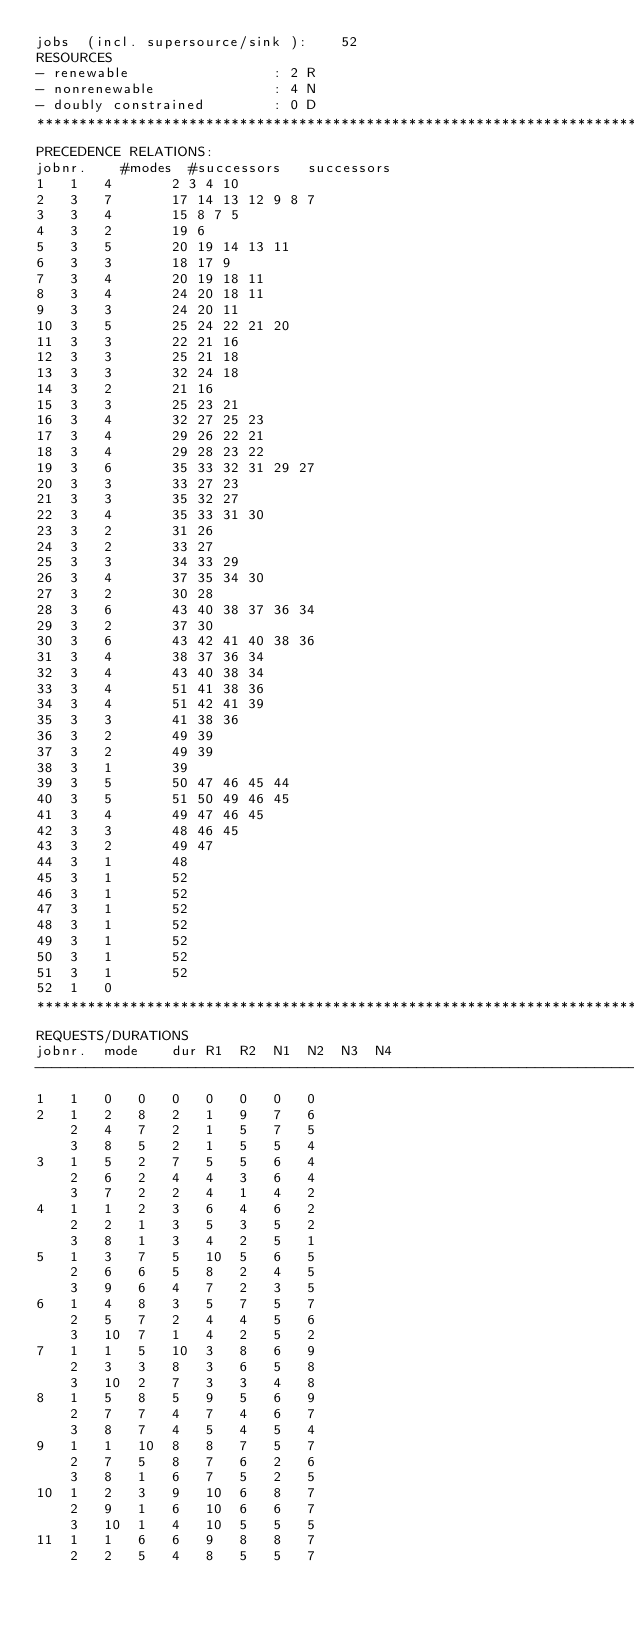Convert code to text. <code><loc_0><loc_0><loc_500><loc_500><_ObjectiveC_>jobs  (incl. supersource/sink ):	52
RESOURCES
- renewable                 : 2 R
- nonrenewable              : 4 N
- doubly constrained        : 0 D
************************************************************************
PRECEDENCE RELATIONS:
jobnr.    #modes  #successors   successors
1	1	4		2 3 4 10 
2	3	7		17 14 13 12 9 8 7 
3	3	4		15 8 7 5 
4	3	2		19 6 
5	3	5		20 19 14 13 11 
6	3	3		18 17 9 
7	3	4		20 19 18 11 
8	3	4		24 20 18 11 
9	3	3		24 20 11 
10	3	5		25 24 22 21 20 
11	3	3		22 21 16 
12	3	3		25 21 18 
13	3	3		32 24 18 
14	3	2		21 16 
15	3	3		25 23 21 
16	3	4		32 27 25 23 
17	3	4		29 26 22 21 
18	3	4		29 28 23 22 
19	3	6		35 33 32 31 29 27 
20	3	3		33 27 23 
21	3	3		35 32 27 
22	3	4		35 33 31 30 
23	3	2		31 26 
24	3	2		33 27 
25	3	3		34 33 29 
26	3	4		37 35 34 30 
27	3	2		30 28 
28	3	6		43 40 38 37 36 34 
29	3	2		37 30 
30	3	6		43 42 41 40 38 36 
31	3	4		38 37 36 34 
32	3	4		43 40 38 34 
33	3	4		51 41 38 36 
34	3	4		51 42 41 39 
35	3	3		41 38 36 
36	3	2		49 39 
37	3	2		49 39 
38	3	1		39 
39	3	5		50 47 46 45 44 
40	3	5		51 50 49 46 45 
41	3	4		49 47 46 45 
42	3	3		48 46 45 
43	3	2		49 47 
44	3	1		48 
45	3	1		52 
46	3	1		52 
47	3	1		52 
48	3	1		52 
49	3	1		52 
50	3	1		52 
51	3	1		52 
52	1	0		
************************************************************************
REQUESTS/DURATIONS
jobnr.	mode	dur	R1	R2	N1	N2	N3	N4	
------------------------------------------------------------------------
1	1	0	0	0	0	0	0	0	
2	1	2	8	2	1	9	7	6	
	2	4	7	2	1	5	7	5	
	3	8	5	2	1	5	5	4	
3	1	5	2	7	5	5	6	4	
	2	6	2	4	4	3	6	4	
	3	7	2	2	4	1	4	2	
4	1	1	2	3	6	4	6	2	
	2	2	1	3	5	3	5	2	
	3	8	1	3	4	2	5	1	
5	1	3	7	5	10	5	6	5	
	2	6	6	5	8	2	4	5	
	3	9	6	4	7	2	3	5	
6	1	4	8	3	5	7	5	7	
	2	5	7	2	4	4	5	6	
	3	10	7	1	4	2	5	2	
7	1	1	5	10	3	8	6	9	
	2	3	3	8	3	6	5	8	
	3	10	2	7	3	3	4	8	
8	1	5	8	5	9	5	6	9	
	2	7	7	4	7	4	6	7	
	3	8	7	4	5	4	5	4	
9	1	1	10	8	8	7	5	7	
	2	7	5	8	7	6	2	6	
	3	8	1	6	7	5	2	5	
10	1	2	3	9	10	6	8	7	
	2	9	1	6	10	6	6	7	
	3	10	1	4	10	5	5	5	
11	1	1	6	6	9	8	8	7	
	2	2	5	4	8	5	5	7	</code> 